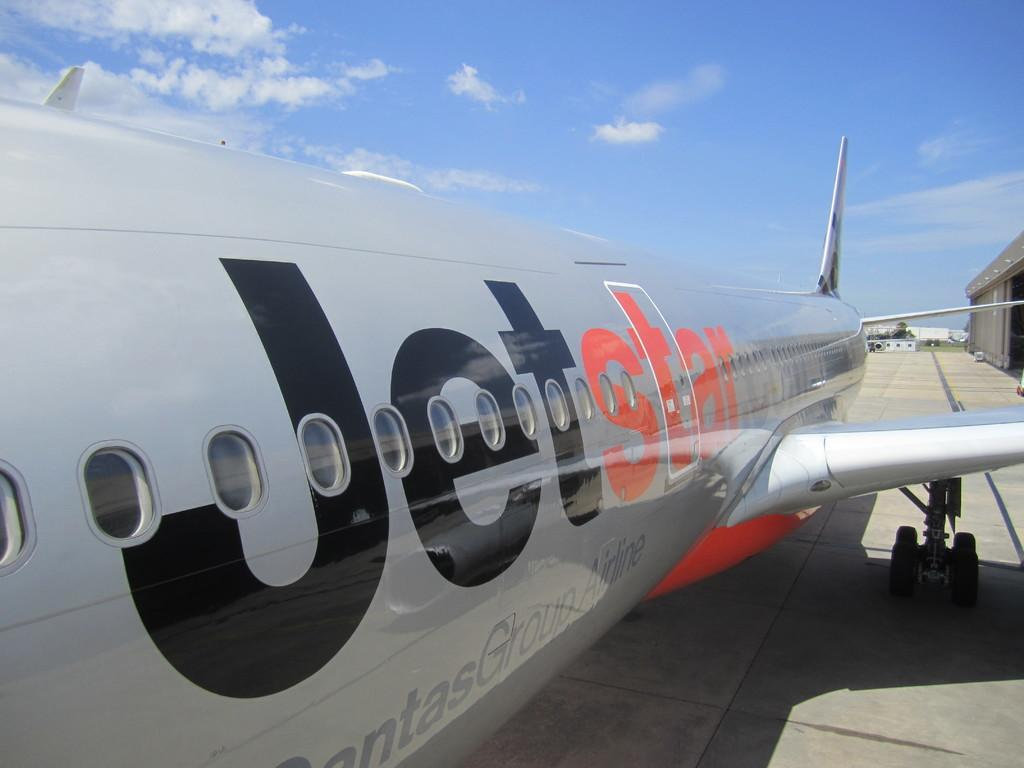<image>
Provide a brief description of the given image. The side of a silver Jetstar plane sitting on a runway. 